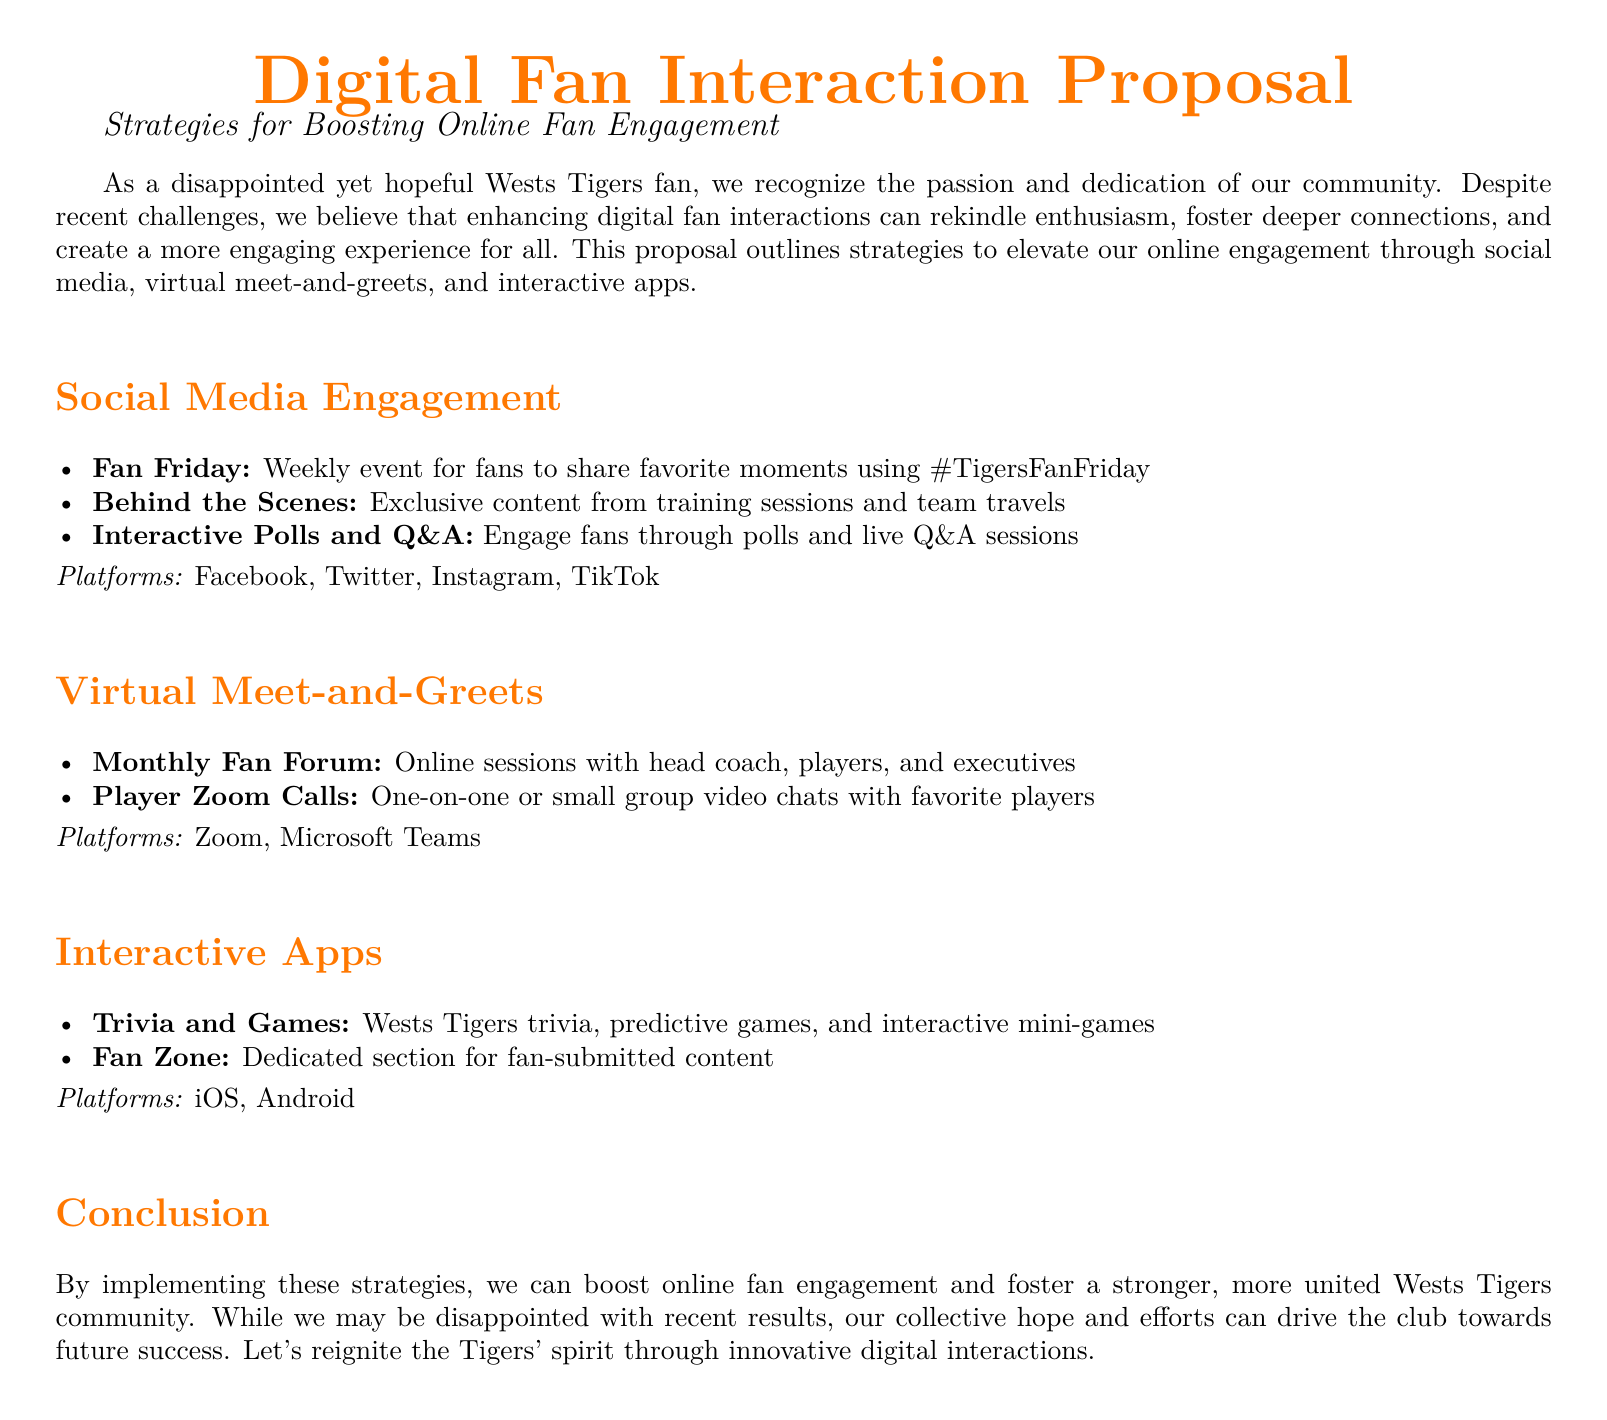what is the title of the proposal? The title is prominently displayed at the top of the document, indicating the proposal's focus.
Answer: Digital Fan Interaction Proposal what is the color used for the section titles? The document specifies a color for the section titles that is distinct from the main text.
Answer: tigersorange how often will the Monthly Fan Forum occur? The frequency of the Monthly Fan Forum is mentioned in the description of the virtual meet-and-greet strategy.
Answer: Monthly which social media platform will feature the Fan Friday event? The specific platform for the Fan Friday event is outlined under the social media engagement section.
Answer: Instagram what type of content is included in the Fan Zone of the interactive app? The document specifies the kind of user-generated content expected in the Fan Zone.
Answer: fan-submitted content what is the objective of the Digital Fan Interaction Proposal? The main goal of the proposal is explained in the introduction, detailing the intent to enhance engagement.
Answer: boost online fan engagement how many types of digital engagement strategies are proposed? The number of distinct strategies outlined in the document indicates the proposal's comprehensive approach.
Answer: Three what type of games will be featured in the interactive apps? The document specifies the kind of games that are part of the interactive apps strategy.
Answer: trivia and games 